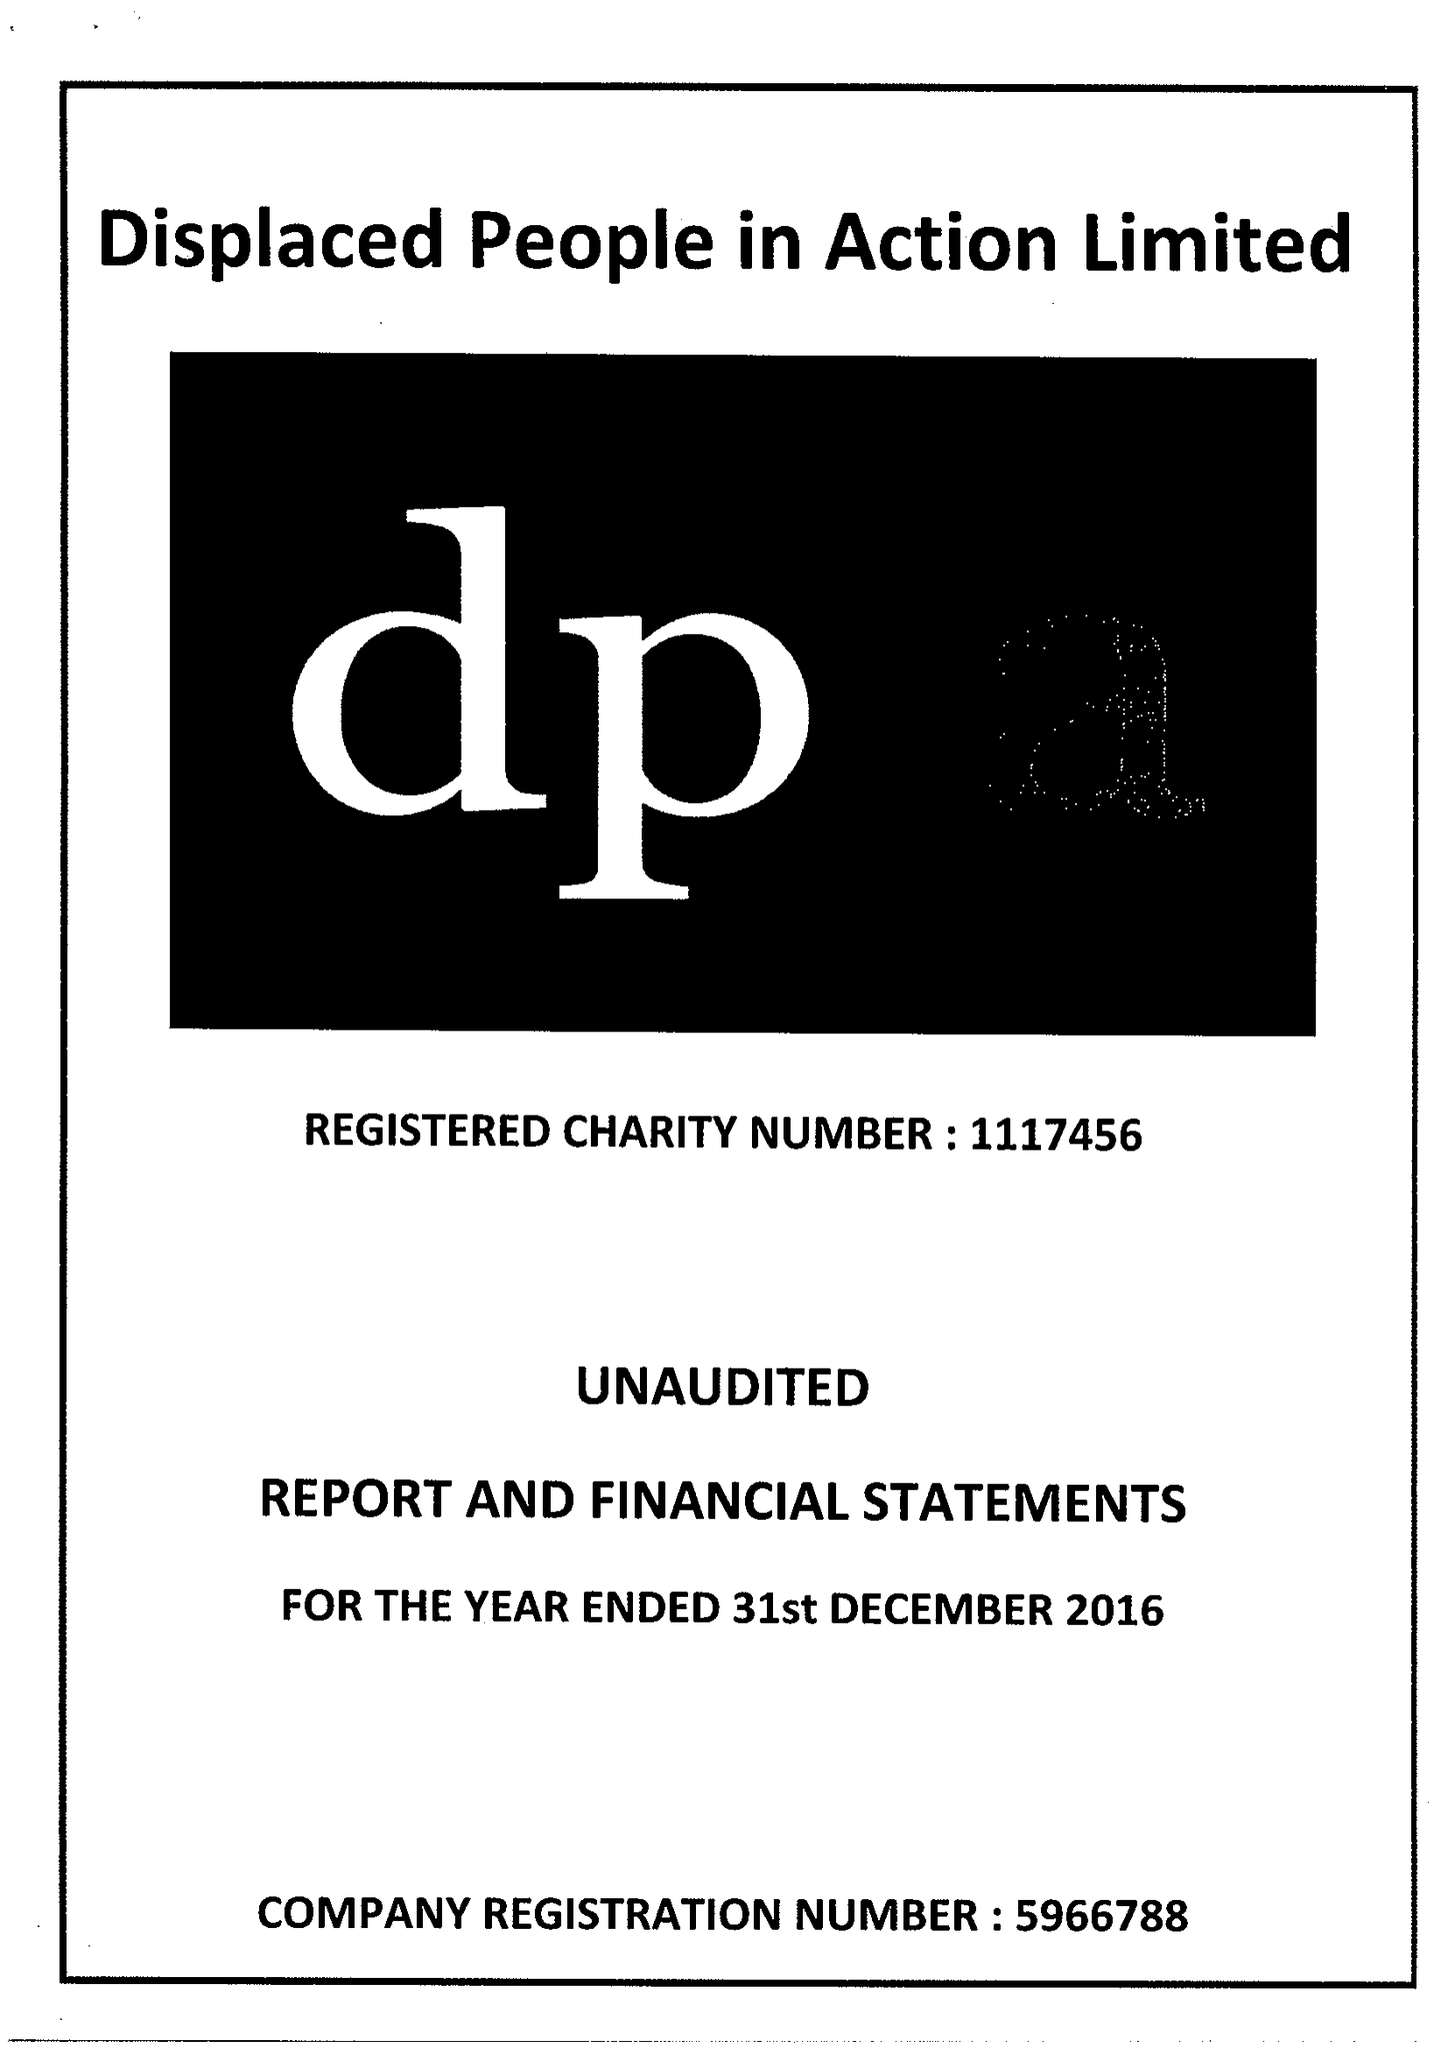What is the value for the charity_name?
Answer the question using a single word or phrase. Displaced People In Action Ltd. 